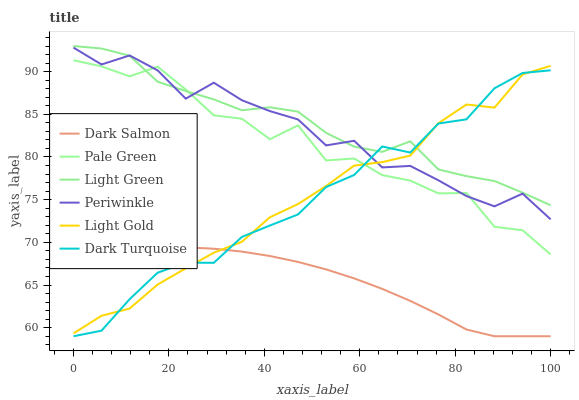Does Dark Salmon have the minimum area under the curve?
Answer yes or no. Yes. Does Light Green have the maximum area under the curve?
Answer yes or no. Yes. Does Pale Green have the minimum area under the curve?
Answer yes or no. No. Does Pale Green have the maximum area under the curve?
Answer yes or no. No. Is Dark Salmon the smoothest?
Answer yes or no. Yes. Is Pale Green the roughest?
Answer yes or no. Yes. Is Pale Green the smoothest?
Answer yes or no. No. Is Dark Salmon the roughest?
Answer yes or no. No. Does Dark Turquoise have the lowest value?
Answer yes or no. Yes. Does Pale Green have the lowest value?
Answer yes or no. No. Does Light Green have the highest value?
Answer yes or no. Yes. Does Pale Green have the highest value?
Answer yes or no. No. Is Dark Salmon less than Light Green?
Answer yes or no. Yes. Is Periwinkle greater than Dark Salmon?
Answer yes or no. Yes. Does Dark Turquoise intersect Pale Green?
Answer yes or no. Yes. Is Dark Turquoise less than Pale Green?
Answer yes or no. No. Is Dark Turquoise greater than Pale Green?
Answer yes or no. No. Does Dark Salmon intersect Light Green?
Answer yes or no. No. 